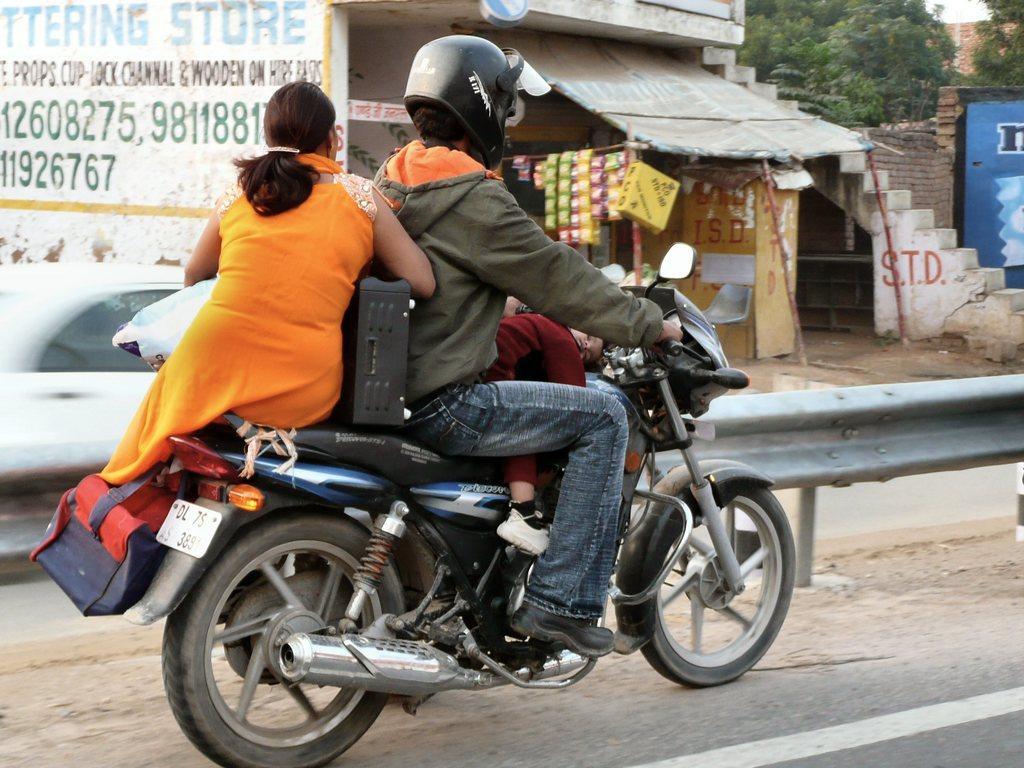Please provide a concise description of this image. In this image I can see a bike and three people on it. In the background I can see a shop and few trees. 